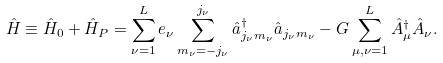Convert formula to latex. <formula><loc_0><loc_0><loc_500><loc_500>\hat { H } \equiv \hat { H } _ { 0 } + \hat { H } _ { P } = \sum _ { \nu = 1 } ^ { L } e _ { \nu } \sum _ { m _ { \nu } = - j _ { \nu } } ^ { j _ { \nu } } \hat { a } ^ { \dagger } _ { j _ { \nu } m _ { \nu } } \hat { a } _ { j _ { \nu } m _ { \nu } } - G \sum _ { \mu , \nu = 1 } ^ { L } \hat { A } ^ { \dagger } _ { \mu } \hat { A } _ { \nu } .</formula> 